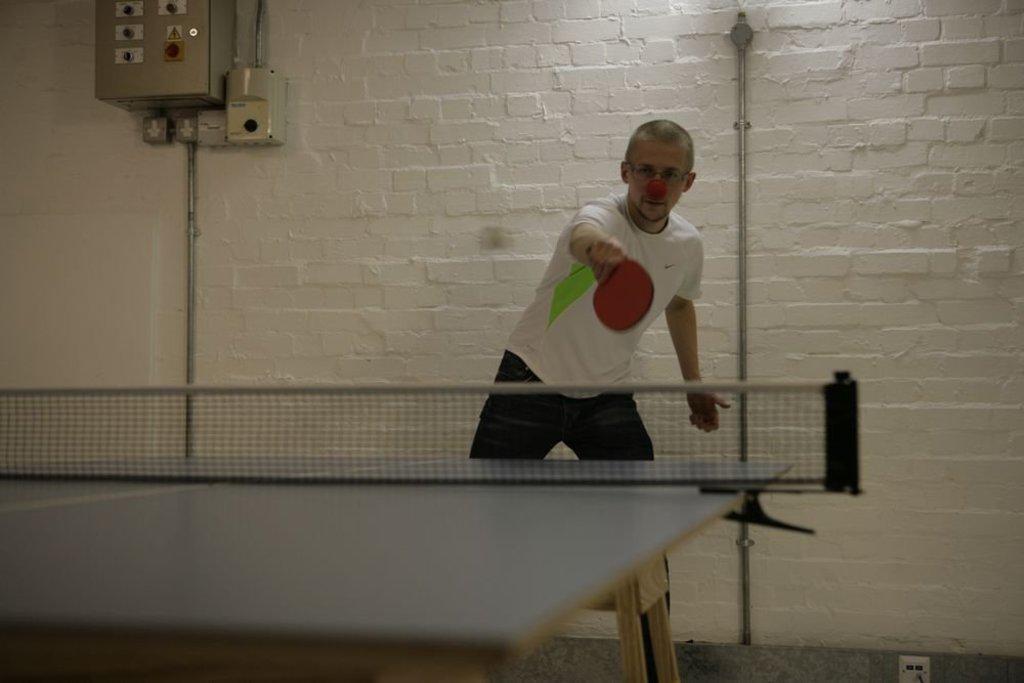In one or two sentences, can you explain what this image depicts? As we can see in the image, there is a man playing badminton. Behind the man there is a white color wall. 